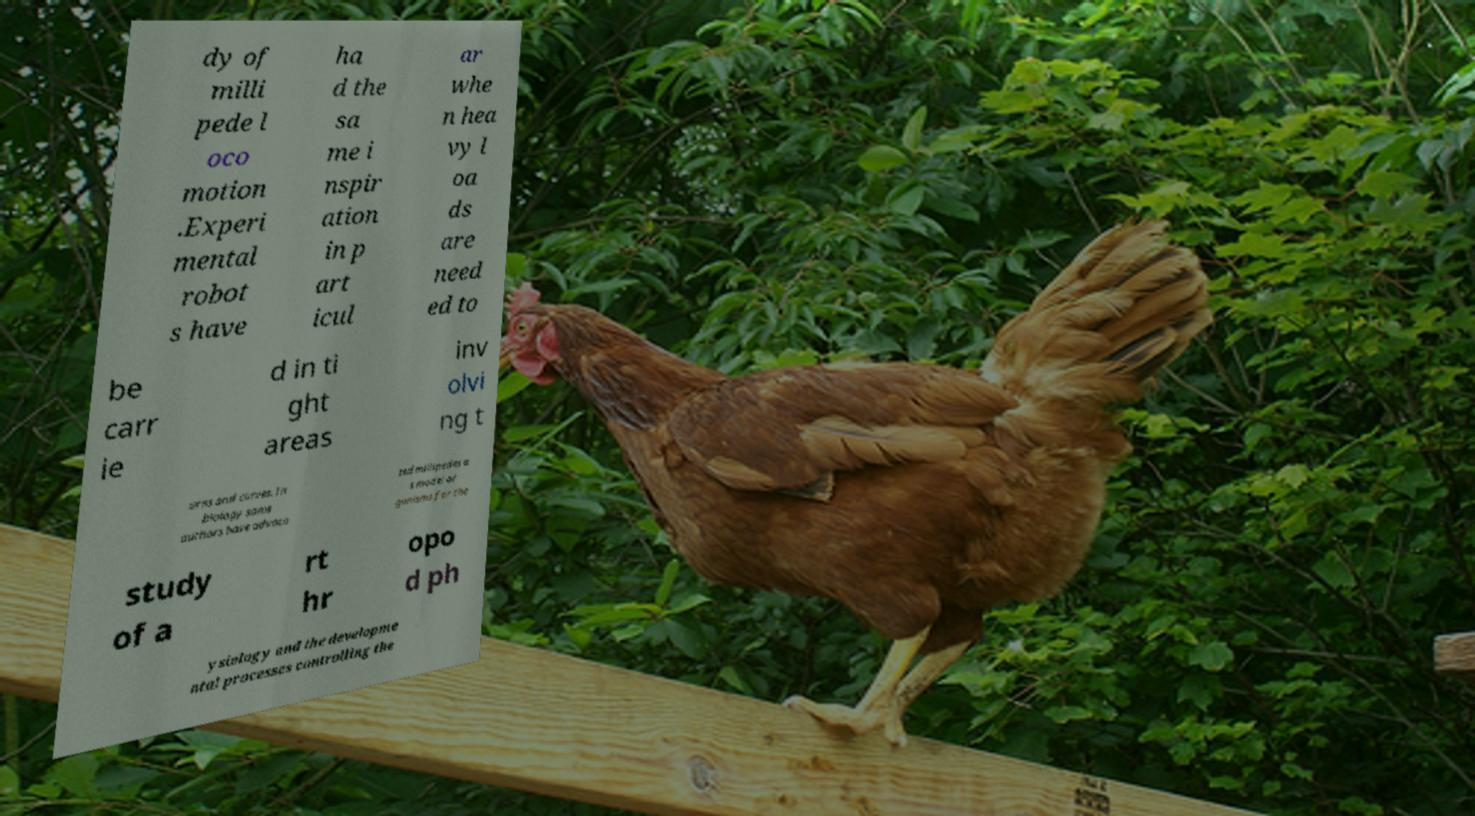Could you assist in decoding the text presented in this image and type it out clearly? dy of milli pede l oco motion .Experi mental robot s have ha d the sa me i nspir ation in p art icul ar whe n hea vy l oa ds are need ed to be carr ie d in ti ght areas inv olvi ng t urns and curves. In biology some authors have advoca ted millipedes a s model or ganisms for the study of a rt hr opo d ph ysiology and the developme ntal processes controlling the 